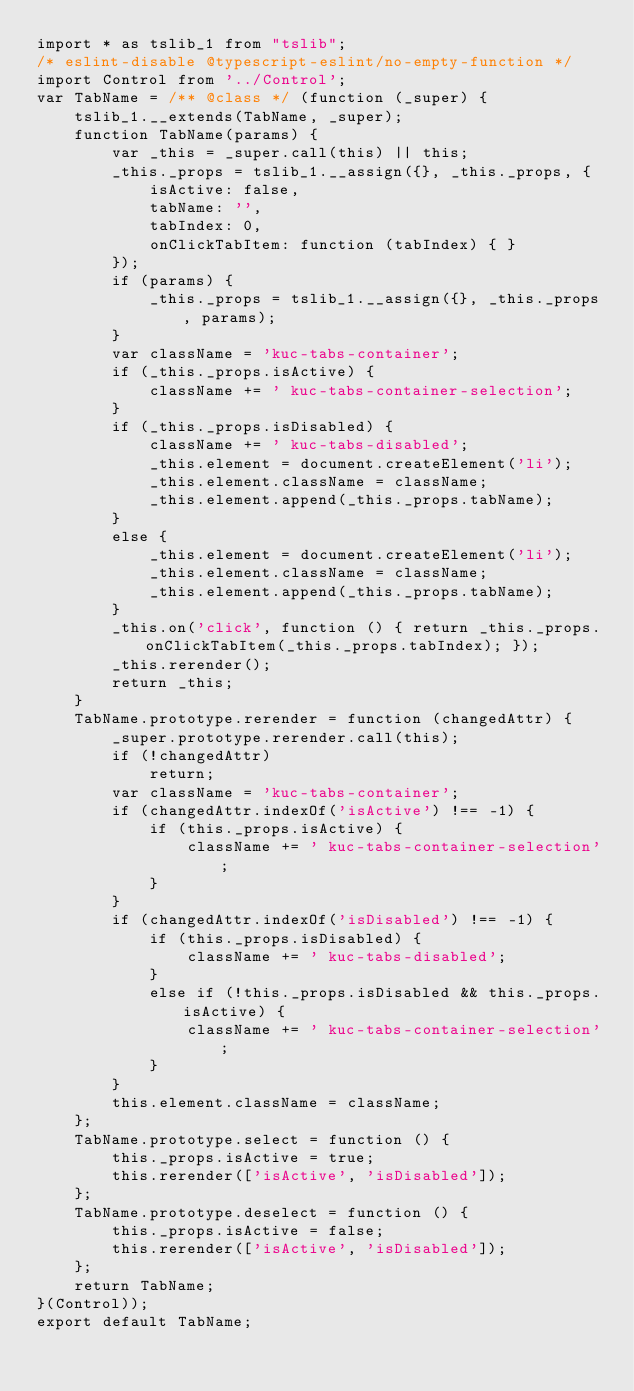<code> <loc_0><loc_0><loc_500><loc_500><_JavaScript_>import * as tslib_1 from "tslib";
/* eslint-disable @typescript-eslint/no-empty-function */
import Control from '../Control';
var TabName = /** @class */ (function (_super) {
    tslib_1.__extends(TabName, _super);
    function TabName(params) {
        var _this = _super.call(this) || this;
        _this._props = tslib_1.__assign({}, _this._props, {
            isActive: false,
            tabName: '',
            tabIndex: 0,
            onClickTabItem: function (tabIndex) { }
        });
        if (params) {
            _this._props = tslib_1.__assign({}, _this._props, params);
        }
        var className = 'kuc-tabs-container';
        if (_this._props.isActive) {
            className += ' kuc-tabs-container-selection';
        }
        if (_this._props.isDisabled) {
            className += ' kuc-tabs-disabled';
            _this.element = document.createElement('li');
            _this.element.className = className;
            _this.element.append(_this._props.tabName);
        }
        else {
            _this.element = document.createElement('li');
            _this.element.className = className;
            _this.element.append(_this._props.tabName);
        }
        _this.on('click', function () { return _this._props.onClickTabItem(_this._props.tabIndex); });
        _this.rerender();
        return _this;
    }
    TabName.prototype.rerender = function (changedAttr) {
        _super.prototype.rerender.call(this);
        if (!changedAttr)
            return;
        var className = 'kuc-tabs-container';
        if (changedAttr.indexOf('isActive') !== -1) {
            if (this._props.isActive) {
                className += ' kuc-tabs-container-selection';
            }
        }
        if (changedAttr.indexOf('isDisabled') !== -1) {
            if (this._props.isDisabled) {
                className += ' kuc-tabs-disabled';
            }
            else if (!this._props.isDisabled && this._props.isActive) {
                className += ' kuc-tabs-container-selection';
            }
        }
        this.element.className = className;
    };
    TabName.prototype.select = function () {
        this._props.isActive = true;
        this.rerender(['isActive', 'isDisabled']);
    };
    TabName.prototype.deselect = function () {
        this._props.isActive = false;
        this.rerender(['isActive', 'isDisabled']);
    };
    return TabName;
}(Control));
export default TabName;
</code> 